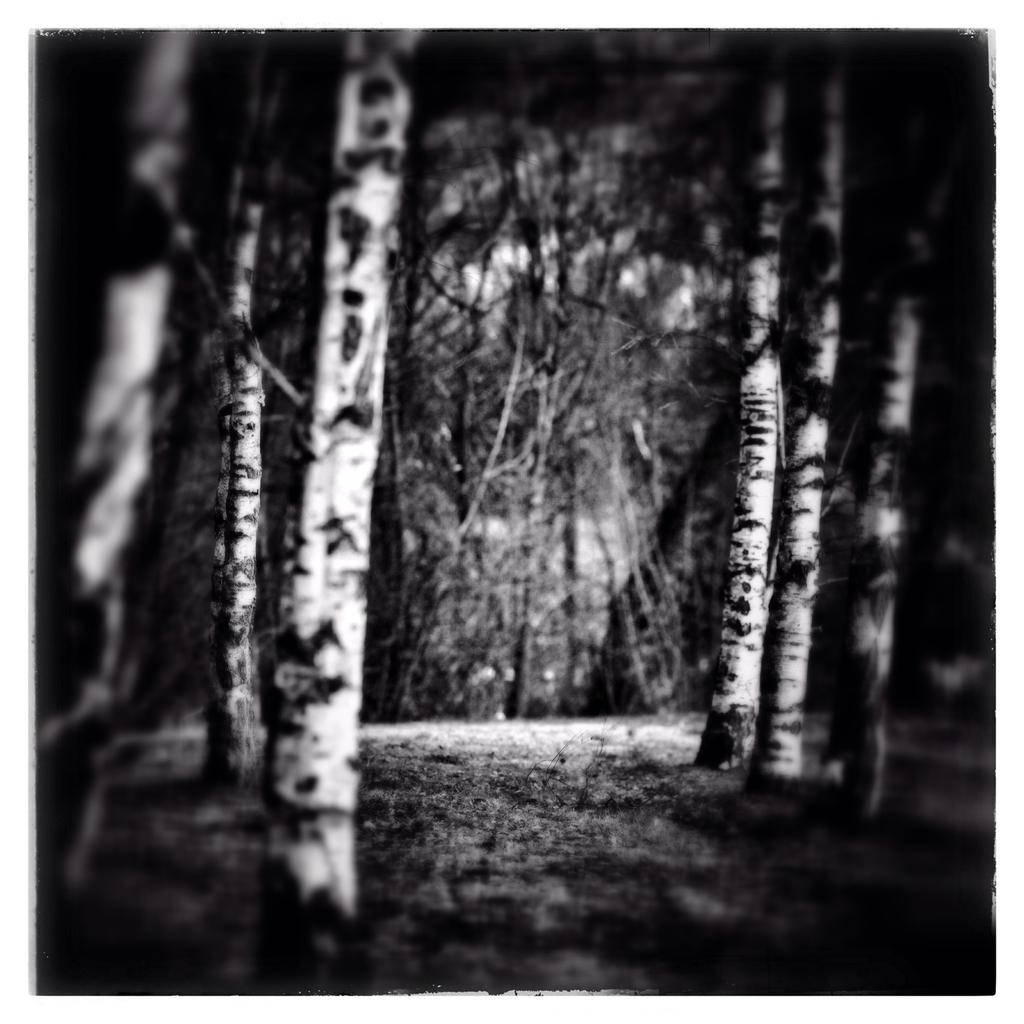What type of vegetation can be seen in the image? There are trees in the image. What color scheme is used in the image? The image is in black and white. Can you see any feathers falling from the trees in the image? There are no feathers visible in the image, and no indication that any are falling from the trees. 